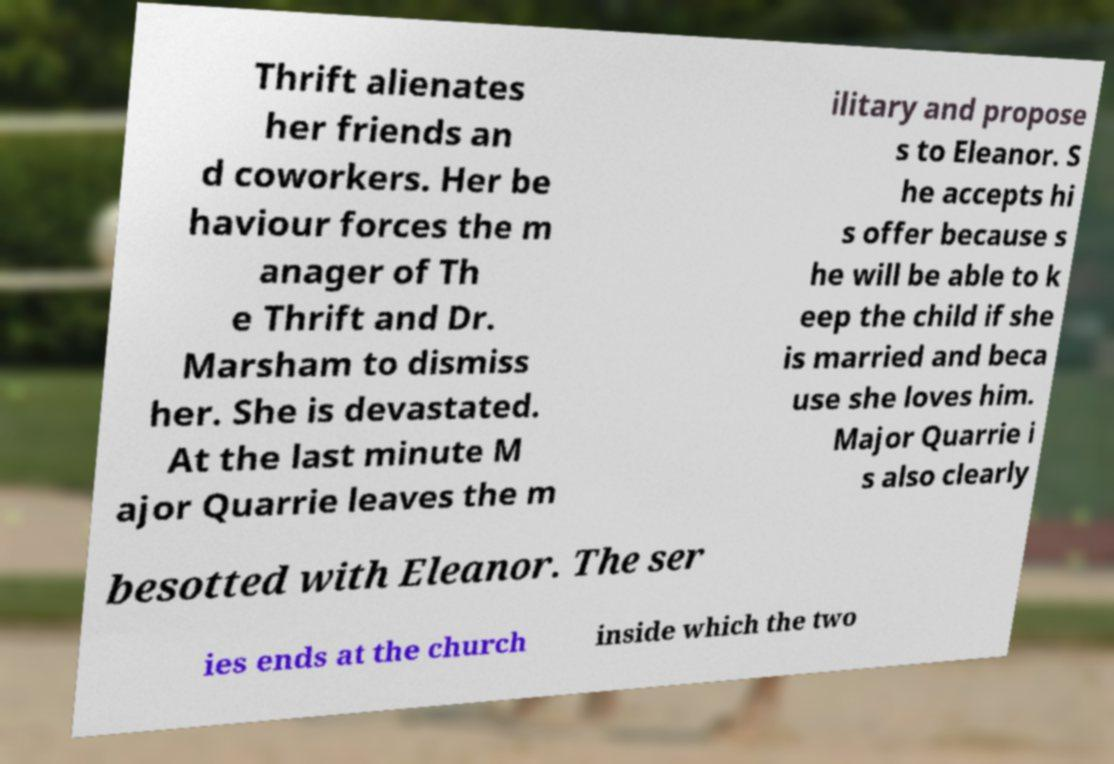For documentation purposes, I need the text within this image transcribed. Could you provide that? Thrift alienates her friends an d coworkers. Her be haviour forces the m anager of Th e Thrift and Dr. Marsham to dismiss her. She is devastated. At the last minute M ajor Quarrie leaves the m ilitary and propose s to Eleanor. S he accepts hi s offer because s he will be able to k eep the child if she is married and beca use she loves him. Major Quarrie i s also clearly besotted with Eleanor. The ser ies ends at the church inside which the two 